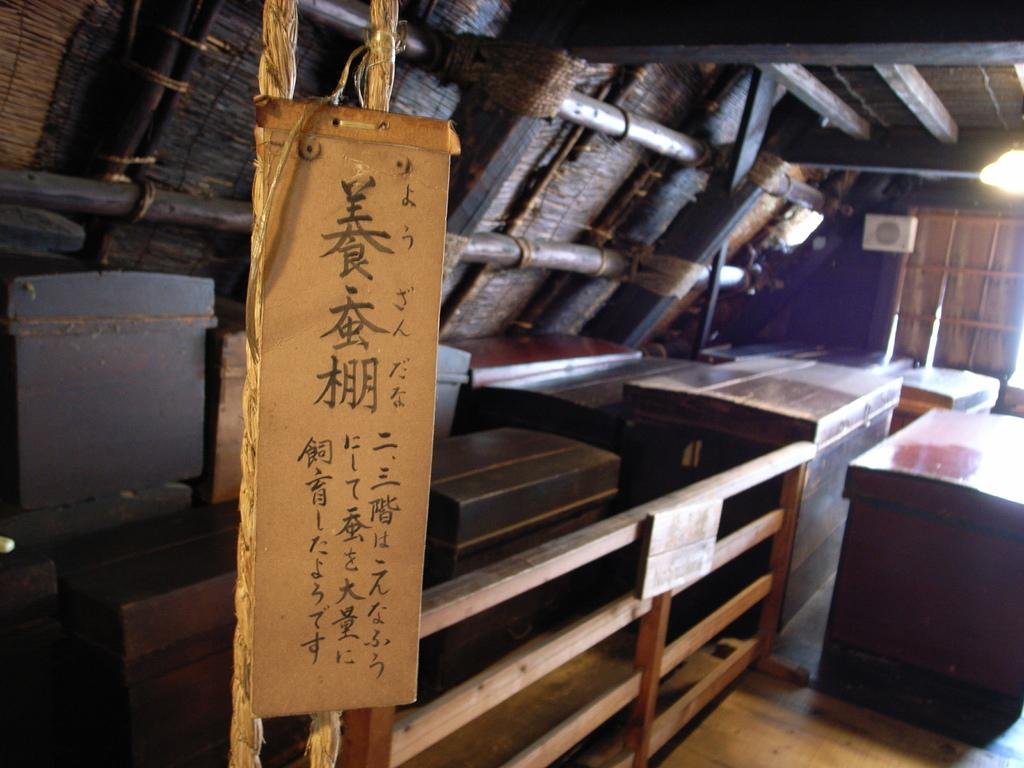What is the main object in the image? There is a board in the image. What can be seen on the floor in the image? There are wooden boxes on the floor in the image. What is visible in the background of the image? There is a window in the image. What provides illumination in the image? There is a light in the image. What type of material is used for the poles in the image? There are wooden poles in the image. Can you describe the objects in the image? There are some objects in the image, but their specific details are not mentioned in the provided facts. What type of fruit is being served with a fork in the image? There is no fruit or fork present in the image; it features a board, wooden boxes, a window, a light, and wooden poles. 